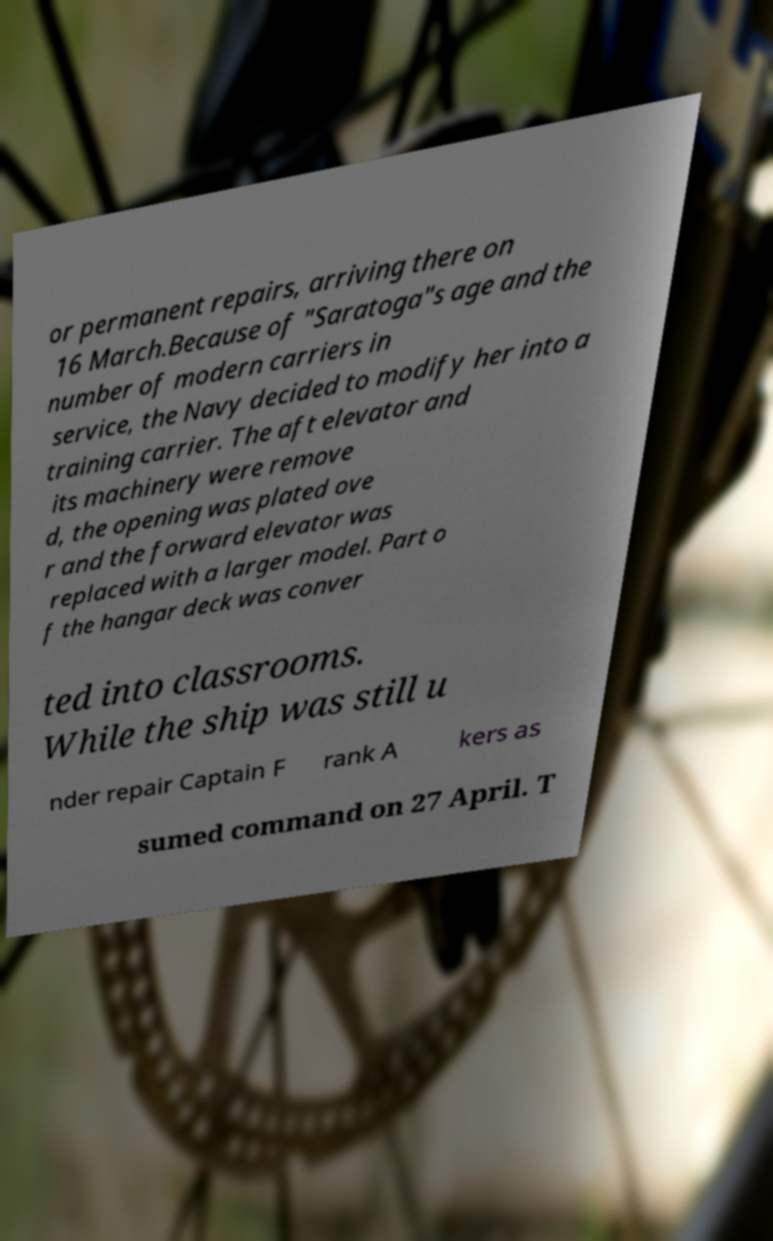I need the written content from this picture converted into text. Can you do that? or permanent repairs, arriving there on 16 March.Because of "Saratoga"s age and the number of modern carriers in service, the Navy decided to modify her into a training carrier. The aft elevator and its machinery were remove d, the opening was plated ove r and the forward elevator was replaced with a larger model. Part o f the hangar deck was conver ted into classrooms. While the ship was still u nder repair Captain F rank A kers as sumed command on 27 April. T 